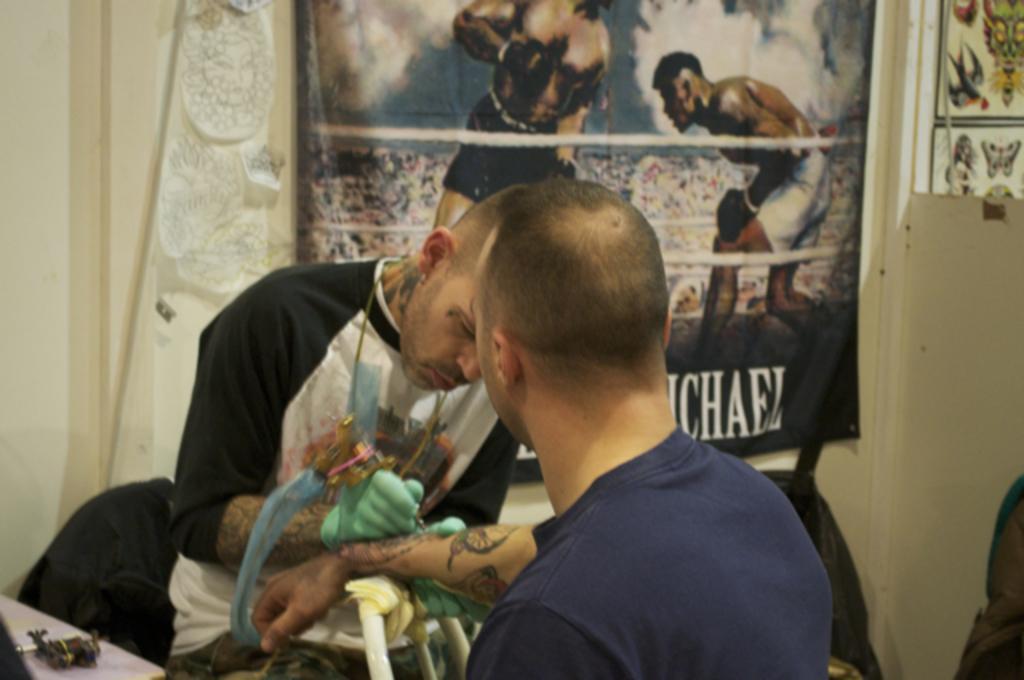Describe this image in one or two sentences. In this image in the front there is a person wearing a blue colour t-shirt and having tattoo in his hand and in the center there is a man doing tattoo. In the background there is a poster on the wall with some text and images on it. 